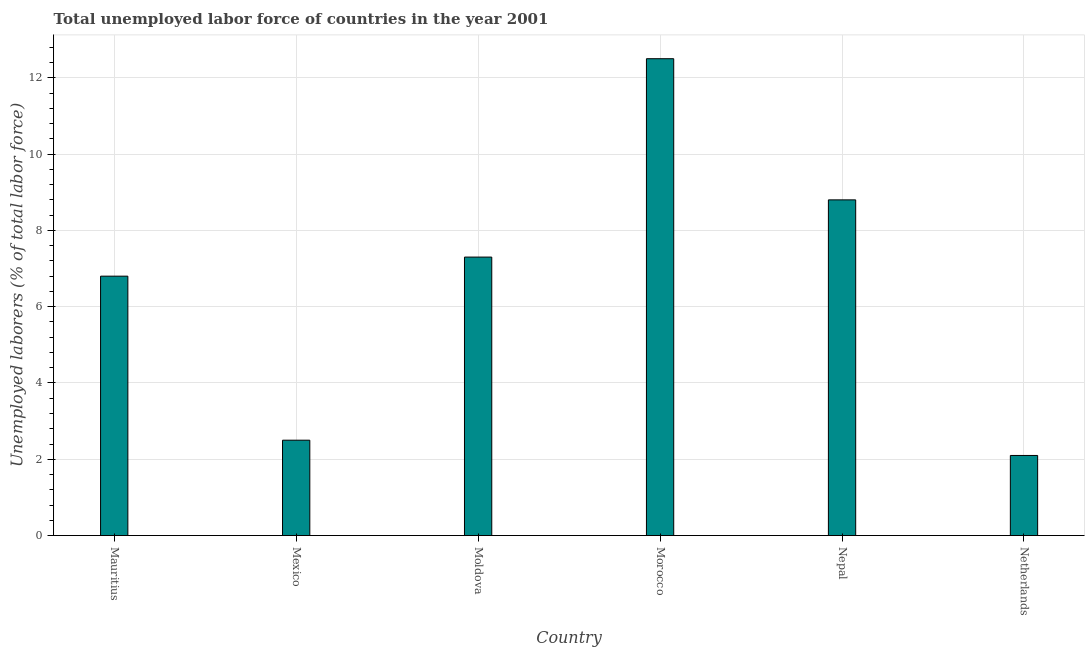Does the graph contain any zero values?
Provide a short and direct response. No. What is the title of the graph?
Give a very brief answer. Total unemployed labor force of countries in the year 2001. What is the label or title of the Y-axis?
Ensure brevity in your answer.  Unemployed laborers (% of total labor force). What is the total unemployed labour force in Netherlands?
Make the answer very short. 2.1. Across all countries, what is the maximum total unemployed labour force?
Provide a succinct answer. 12.5. Across all countries, what is the minimum total unemployed labour force?
Offer a very short reply. 2.1. In which country was the total unemployed labour force maximum?
Give a very brief answer. Morocco. In which country was the total unemployed labour force minimum?
Provide a short and direct response. Netherlands. What is the sum of the total unemployed labour force?
Provide a succinct answer. 40. What is the difference between the total unemployed labour force in Mexico and Nepal?
Make the answer very short. -6.3. What is the average total unemployed labour force per country?
Make the answer very short. 6.67. What is the median total unemployed labour force?
Offer a terse response. 7.05. What is the ratio of the total unemployed labour force in Mexico to that in Nepal?
Ensure brevity in your answer.  0.28. Is the difference between the total unemployed labour force in Mauritius and Mexico greater than the difference between any two countries?
Keep it short and to the point. No. What is the difference between the highest and the second highest total unemployed labour force?
Your answer should be compact. 3.7. What is the difference between the highest and the lowest total unemployed labour force?
Provide a short and direct response. 10.4. In how many countries, is the total unemployed labour force greater than the average total unemployed labour force taken over all countries?
Your answer should be compact. 4. Are all the bars in the graph horizontal?
Make the answer very short. No. How many countries are there in the graph?
Ensure brevity in your answer.  6. Are the values on the major ticks of Y-axis written in scientific E-notation?
Your response must be concise. No. What is the Unemployed laborers (% of total labor force) of Mauritius?
Offer a terse response. 6.8. What is the Unemployed laborers (% of total labor force) of Moldova?
Offer a terse response. 7.3. What is the Unemployed laborers (% of total labor force) of Nepal?
Provide a succinct answer. 8.8. What is the Unemployed laborers (% of total labor force) of Netherlands?
Offer a very short reply. 2.1. What is the difference between the Unemployed laborers (% of total labor force) in Mauritius and Mexico?
Your answer should be very brief. 4.3. What is the difference between the Unemployed laborers (% of total labor force) in Mauritius and Netherlands?
Make the answer very short. 4.7. What is the difference between the Unemployed laborers (% of total labor force) in Mexico and Moldova?
Your answer should be compact. -4.8. What is the difference between the Unemployed laborers (% of total labor force) in Mexico and Morocco?
Offer a very short reply. -10. What is the difference between the Unemployed laborers (% of total labor force) in Mexico and Netherlands?
Ensure brevity in your answer.  0.4. What is the difference between the Unemployed laborers (% of total labor force) in Moldova and Morocco?
Offer a terse response. -5.2. What is the difference between the Unemployed laborers (% of total labor force) in Moldova and Nepal?
Provide a short and direct response. -1.5. What is the difference between the Unemployed laborers (% of total labor force) in Morocco and Nepal?
Offer a terse response. 3.7. What is the ratio of the Unemployed laborers (% of total labor force) in Mauritius to that in Mexico?
Your answer should be very brief. 2.72. What is the ratio of the Unemployed laborers (% of total labor force) in Mauritius to that in Moldova?
Ensure brevity in your answer.  0.93. What is the ratio of the Unemployed laborers (% of total labor force) in Mauritius to that in Morocco?
Provide a succinct answer. 0.54. What is the ratio of the Unemployed laborers (% of total labor force) in Mauritius to that in Nepal?
Keep it short and to the point. 0.77. What is the ratio of the Unemployed laborers (% of total labor force) in Mauritius to that in Netherlands?
Give a very brief answer. 3.24. What is the ratio of the Unemployed laborers (% of total labor force) in Mexico to that in Moldova?
Provide a short and direct response. 0.34. What is the ratio of the Unemployed laborers (% of total labor force) in Mexico to that in Morocco?
Offer a very short reply. 0.2. What is the ratio of the Unemployed laborers (% of total labor force) in Mexico to that in Nepal?
Your answer should be compact. 0.28. What is the ratio of the Unemployed laborers (% of total labor force) in Mexico to that in Netherlands?
Offer a terse response. 1.19. What is the ratio of the Unemployed laborers (% of total labor force) in Moldova to that in Morocco?
Provide a short and direct response. 0.58. What is the ratio of the Unemployed laborers (% of total labor force) in Moldova to that in Nepal?
Ensure brevity in your answer.  0.83. What is the ratio of the Unemployed laborers (% of total labor force) in Moldova to that in Netherlands?
Make the answer very short. 3.48. What is the ratio of the Unemployed laborers (% of total labor force) in Morocco to that in Nepal?
Provide a succinct answer. 1.42. What is the ratio of the Unemployed laborers (% of total labor force) in Morocco to that in Netherlands?
Your response must be concise. 5.95. What is the ratio of the Unemployed laborers (% of total labor force) in Nepal to that in Netherlands?
Keep it short and to the point. 4.19. 